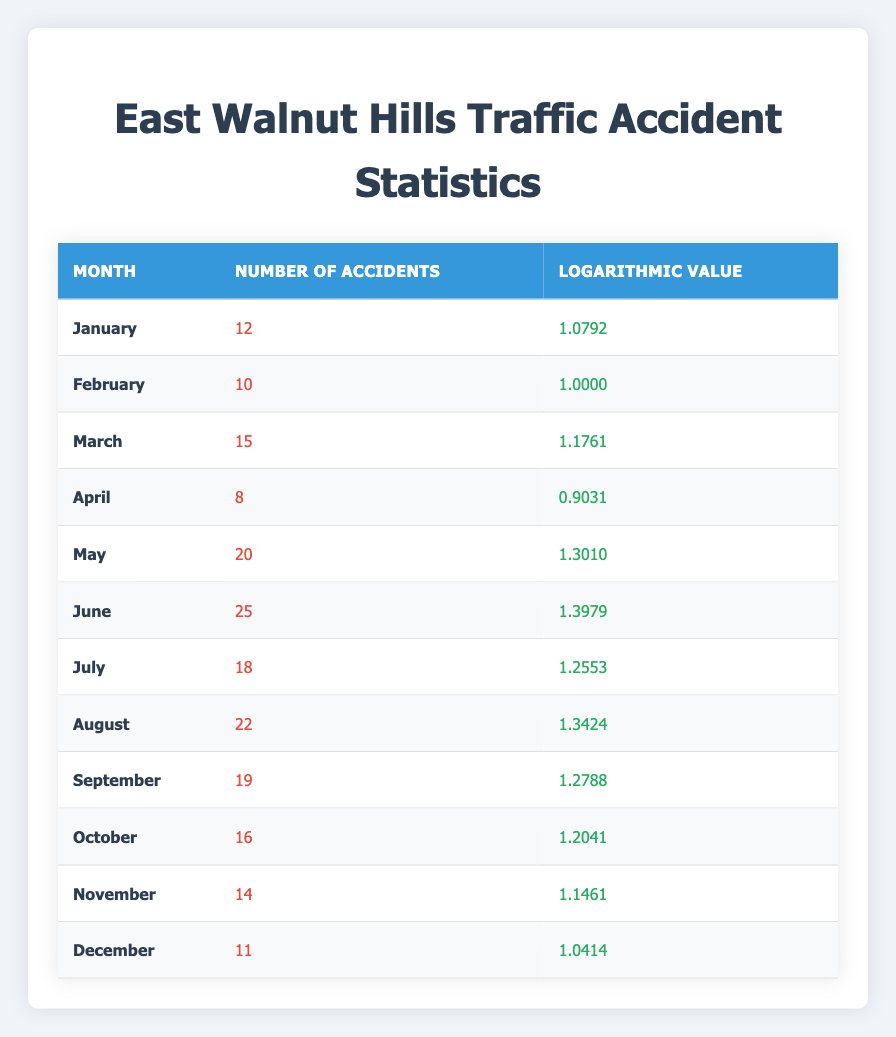What was the month with the highest number of accidents? By reviewing the "Number of Accidents" column, June has the highest value of 25 accidents compared to other months.
Answer: June How many accidents occurred in March? The table directly shows that there were 15 accidents in March.
Answer: 15 Is it true that the number of accidents in December is less than in February? December had 11 accidents, and February had 10 accidents. Since 11 is greater than 10, the statement is false.
Answer: No What is the total number of accidents from May to August? We sum the number of accidents from May (20), June (25), July (18), and August (22): 20 + 25 + 18 + 22 = 85.
Answer: 85 What is the average number of accidents from January to April? The total number of accidents from January (12), February (10), March (15), and April (8) is 12 + 10 + 15 + 8 = 45. Dividing by 4 (the number of months), we get 45 / 4 = 11.25.
Answer: 11.25 Which month had a logarithmic value closest to 1? The logarithmic value for February is 1.0000, which is exactly 1. It is the only month with this value.
Answer: February How many more accidents were there in June than in January? June had 25 accidents, and January had 12 accidents. The difference is 25 - 12 = 13 accidents.
Answer: 13 Is the logarithmic value for April lower than 1? The logarithmic value for April is 0.9031, which is indeed less than 1. Hence, the statement is true.
Answer: Yes What is the total number of accidents over the entire year? To find the total, we add the number of accidents for all months: 12 + 10 + 15 + 8 + 20 + 25 + 18 + 22 + 19 + 16 + 14 + 11 =  210.
Answer: 210 